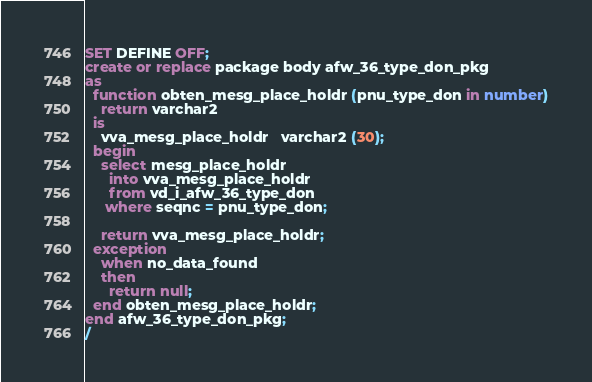<code> <loc_0><loc_0><loc_500><loc_500><_SQL_>SET DEFINE OFF;
create or replace package body afw_36_type_don_pkg
as
  function obten_mesg_place_holdr (pnu_type_don in number)
    return varchar2
  is
    vva_mesg_place_holdr   varchar2 (30);
  begin
    select mesg_place_holdr
      into vva_mesg_place_holdr
      from vd_i_afw_36_type_don
     where seqnc = pnu_type_don;

    return vva_mesg_place_holdr;
  exception
    when no_data_found
    then
      return null;
  end obten_mesg_place_holdr;
end afw_36_type_don_pkg;
/
</code> 